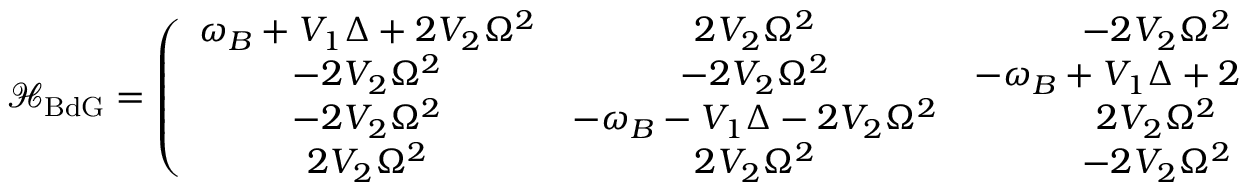Convert formula to latex. <formula><loc_0><loc_0><loc_500><loc_500>\mathcal { H } _ { B d G } = \left ( \begin{array} { c c c c } { \omega _ { B } + V _ { 1 } \Delta + 2 V _ { 2 } \Omega ^ { 2 } } & { 2 V _ { 2 } \Omega ^ { 2 } } & { - 2 V _ { 2 } \Omega ^ { 2 } } & { - 2 V _ { 2 } \Omega ^ { 2 } } \\ { - 2 V _ { 2 } \Omega ^ { 2 } } & { - 2 V _ { 2 } \Omega ^ { 2 } } & { - \omega _ { B } + V _ { 1 } \Delta + 2 V _ { 2 } \Omega ^ { 2 } } & { 2 V _ { 2 } \Omega ^ { 2 } } \\ { - 2 V _ { 2 } \Omega ^ { 2 } } & { - \omega _ { B } - V _ { 1 } \Delta - 2 V _ { 2 } \Omega ^ { 2 } } & { 2 V _ { 2 } \Omega ^ { 2 } } & { 2 V _ { 2 } \Omega ^ { 2 } } \\ { 2 V _ { 2 } \Omega ^ { 2 } } & { 2 V _ { 2 } \Omega ^ { 2 } } & { - 2 V _ { 2 } \Omega ^ { 2 } } & { \omega _ { B } - V _ { 1 } \Delta - 2 V _ { 2 } \Omega ^ { 2 } } \end{array} \right ) .</formula> 